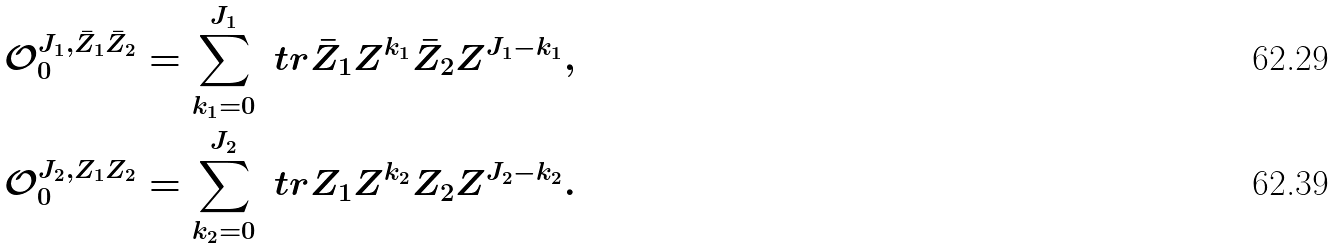<formula> <loc_0><loc_0><loc_500><loc_500>\mathcal { O } ^ { J _ { 1 } , \bar { Z } _ { 1 } \bar { Z } _ { 2 } } _ { 0 } = \sum _ { k _ { 1 } = 0 } ^ { J _ { 1 } } \ t r { \bar { Z } _ { 1 } Z ^ { k _ { 1 } } \bar { Z } _ { 2 } Z ^ { J _ { 1 } - k _ { 1 } } } , \\ \mathcal { O } ^ { J _ { 2 } , Z _ { 1 } Z _ { 2 } } _ { 0 } = \sum _ { k _ { 2 } = 0 } ^ { J _ { 2 } } \ t r { Z _ { 1 } Z ^ { k _ { 2 } } Z _ { 2 } Z ^ { J _ { 2 } - k _ { 2 } } } .</formula> 